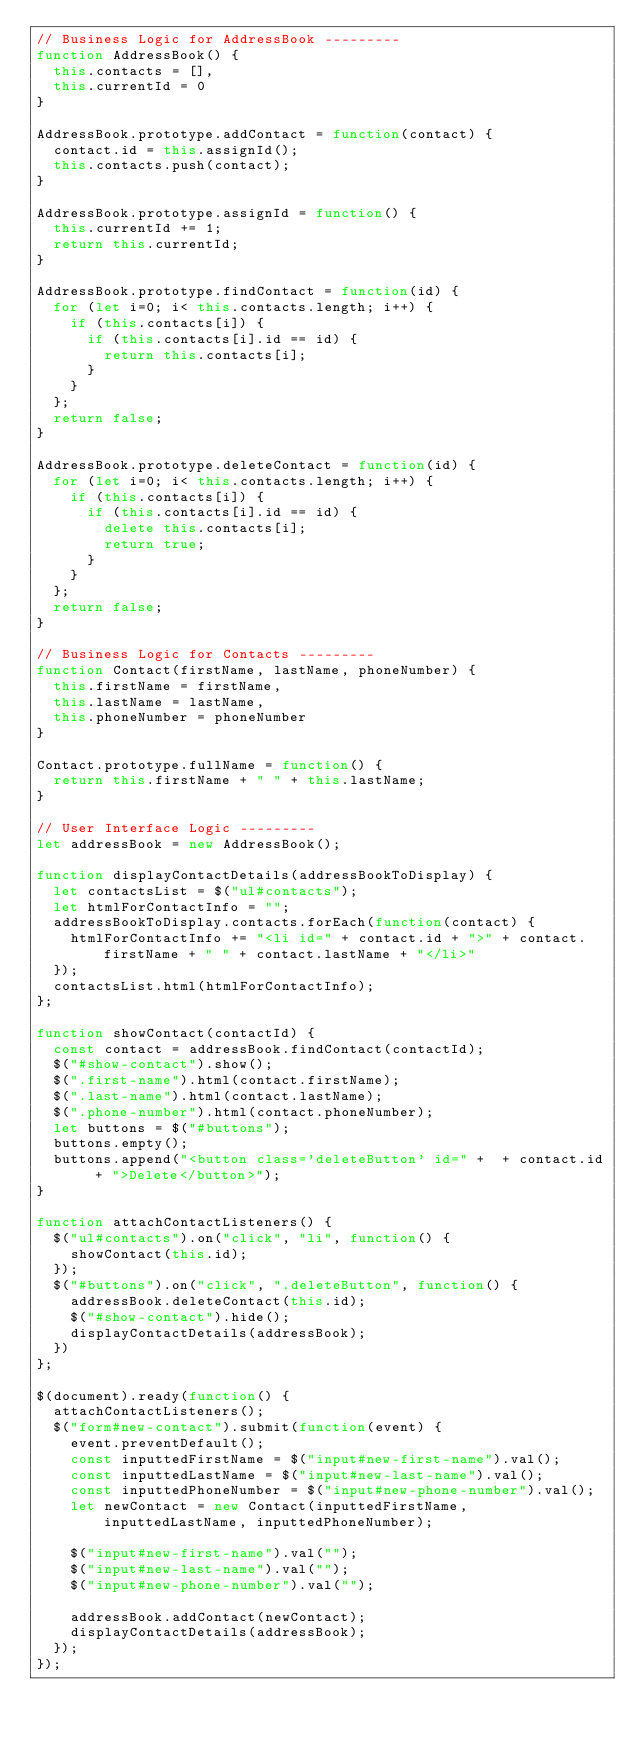<code> <loc_0><loc_0><loc_500><loc_500><_JavaScript_>// Business Logic for AddressBook ---------
function AddressBook() {
  this.contacts = [],
  this.currentId = 0
}

AddressBook.prototype.addContact = function(contact) {
  contact.id = this.assignId();
  this.contacts.push(contact);
}

AddressBook.prototype.assignId = function() {
  this.currentId += 1;
  return this.currentId;
}

AddressBook.prototype.findContact = function(id) {
  for (let i=0; i< this.contacts.length; i++) {
    if (this.contacts[i]) {
      if (this.contacts[i].id == id) {
        return this.contacts[i];
      }
    }
  };
  return false;
}

AddressBook.prototype.deleteContact = function(id) {
  for (let i=0; i< this.contacts.length; i++) {
    if (this.contacts[i]) {
      if (this.contacts[i].id == id) {
        delete this.contacts[i];
        return true;
      }
    }
  };
  return false;
}

// Business Logic for Contacts ---------
function Contact(firstName, lastName, phoneNumber) {
  this.firstName = firstName,
  this.lastName = lastName,
  this.phoneNumber = phoneNumber
}

Contact.prototype.fullName = function() {
  return this.firstName + " " + this.lastName;
}

// User Interface Logic ---------
let addressBook = new AddressBook();

function displayContactDetails(addressBookToDisplay) {
  let contactsList = $("ul#contacts");
  let htmlForContactInfo = "";
  addressBookToDisplay.contacts.forEach(function(contact) {
    htmlForContactInfo += "<li id=" + contact.id + ">" + contact.firstName + " " + contact.lastName + "</li>"
  });
  contactsList.html(htmlForContactInfo);
};

function showContact(contactId) {
  const contact = addressBook.findContact(contactId);
  $("#show-contact").show();
  $(".first-name").html(contact.firstName);
  $(".last-name").html(contact.lastName);
  $(".phone-number").html(contact.phoneNumber);
  let buttons = $("#buttons");
  buttons.empty();
  buttons.append("<button class='deleteButton' id=" +  + contact.id + ">Delete</button>");
}

function attachContactListeners() {
  $("ul#contacts").on("click", "li", function() {
    showContact(this.id);
  });
  $("#buttons").on("click", ".deleteButton", function() {
    addressBook.deleteContact(this.id);
    $("#show-contact").hide();
    displayContactDetails(addressBook);
  })
};

$(document).ready(function() {
  attachContactListeners();
  $("form#new-contact").submit(function(event) {
    event.preventDefault();
    const inputtedFirstName = $("input#new-first-name").val();
    const inputtedLastName = $("input#new-last-name").val();
    const inputtedPhoneNumber = $("input#new-phone-number").val();
    let newContact = new Contact(inputtedFirstName, inputtedLastName, inputtedPhoneNumber);

    $("input#new-first-name").val("");
    $("input#new-last-name").val("");
    $("input#new-phone-number").val("");

    addressBook.addContact(newContact);
    displayContactDetails(addressBook);
  });
});</code> 